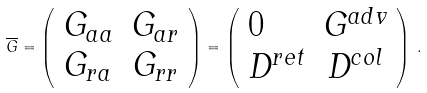Convert formula to latex. <formula><loc_0><loc_0><loc_500><loc_500>\overline { G } = \left ( \begin{array} { l c r } { { G _ { a a } } } & { { G _ { a r } } } \\ { { G _ { r a } } } & { { G _ { r r } } } \end{array} \right ) = \left ( \begin{array} { l c r } { 0 } & { { G ^ { a d v } } } \\ { { D ^ { r e t } } } & { { D ^ { c o l } } } \end{array} \right ) \, .</formula> 